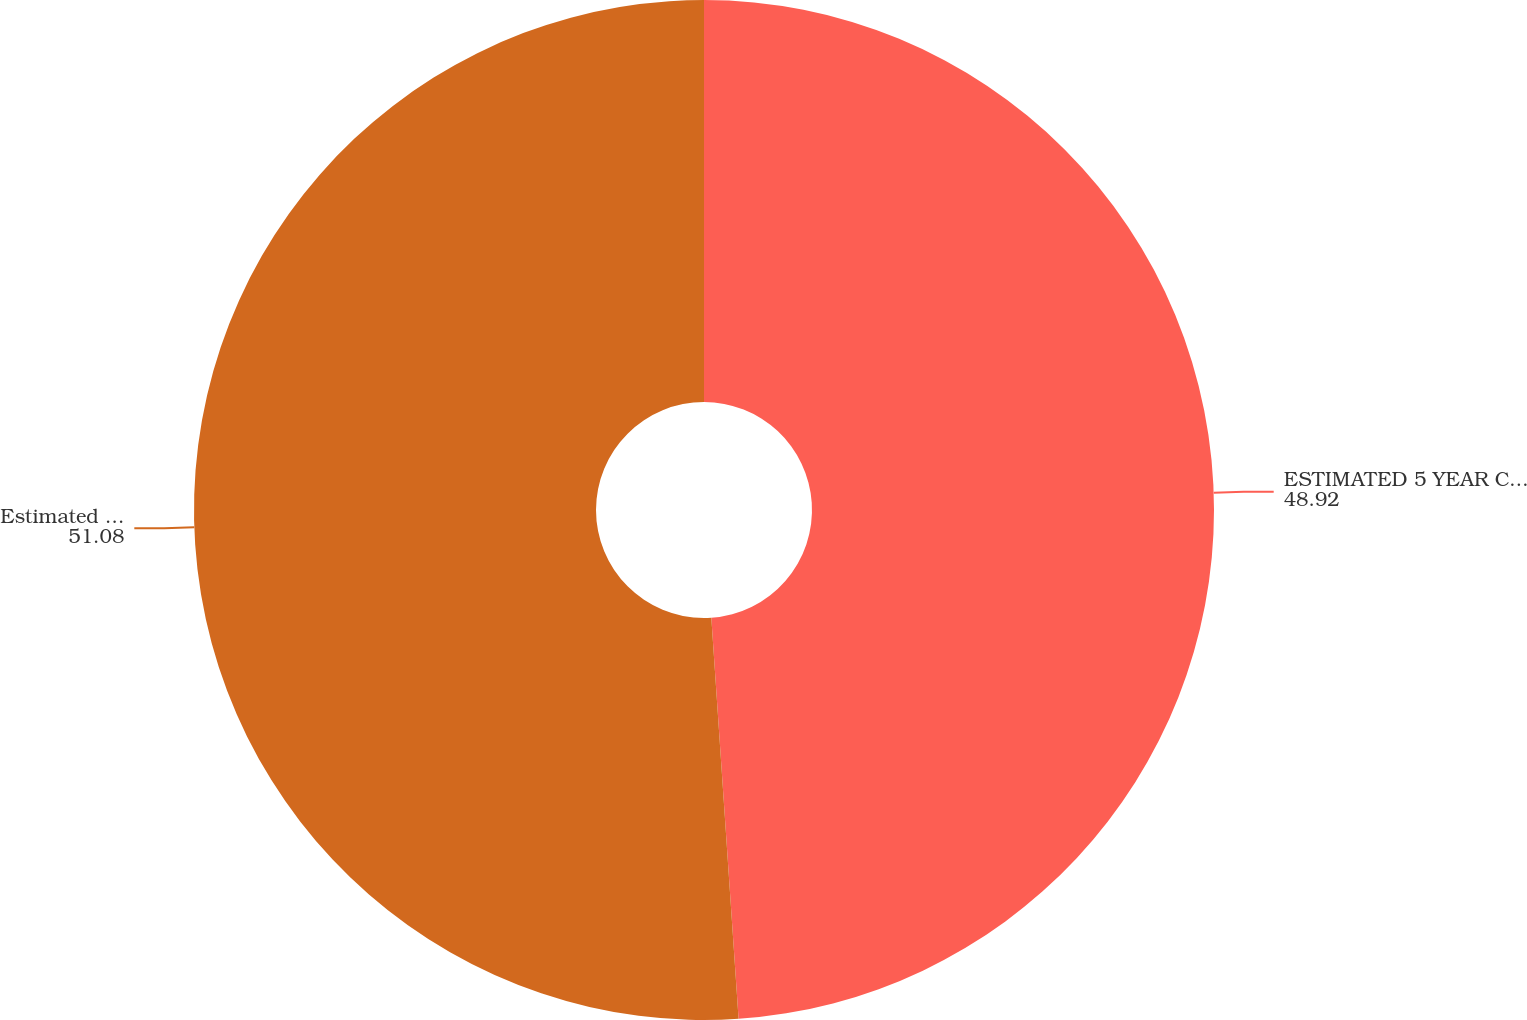<chart> <loc_0><loc_0><loc_500><loc_500><pie_chart><fcel>ESTIMATED 5 YEAR CONSOLIDATED<fcel>Estimated annual pre-tax<nl><fcel>48.92%<fcel>51.08%<nl></chart> 